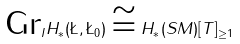Convert formula to latex. <formula><loc_0><loc_0><loc_500><loc_500>\text {Gr} _ { I } H _ { * } ( \L , \L _ { 0 } ) \cong H _ { * } ( S M ) [ T ] _ { \geq 1 }</formula> 